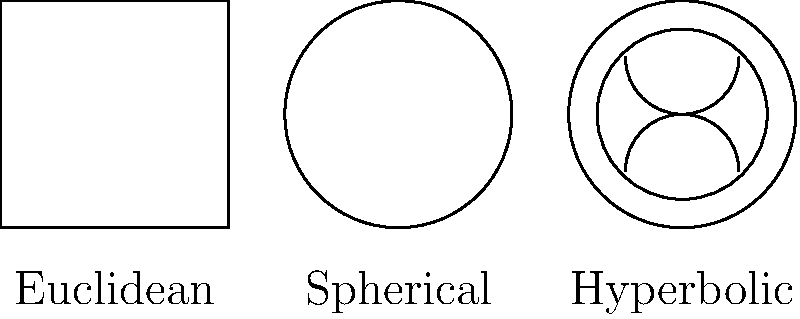In the context of implementing SharePoint solutions, understanding different geometric models can be useful for designing user interfaces and data visualizations. Consider the diagram showing Euclidean, spherical, and hyperbolic geometries. Which of these geometries allows for the existence of parallel lines, and how does this property differ in the other geometries? To answer this question, let's analyze each geometry:

1. Euclidean Geometry:
   - Parallel lines exist and never intersect.
   - The sum of angles in a triangle is always 180°.

2. Spherical Geometry:
   - No parallel lines exist; all great circles (the equivalent of straight lines on a sphere) eventually intersect.
   - The sum of angles in a triangle is always greater than 180°.

3. Hyperbolic Geometry:
   - Multiple parallel lines can exist through a point not on a given line.
   - The sum of angles in a triangle is always less than 180°.

In the context of SharePoint:
- Euclidean geometry is most commonly used in traditional 2D interfaces.
- Spherical geometry could be useful for global data visualization or 360° content presentation.
- Hyperbolic geometry can be applied to visualize hierarchical structures or complex networks, allowing for more efficient use of space in large datasets.

The key difference is that only Euclidean geometry allows for the existence of parallel lines in the traditional sense. In spherical geometry, all lines (great circles) intersect, while in hyperbolic geometry, multiple parallels can exist through a point not on a given line.
Answer: Euclidean geometry allows parallel lines; spherical has no parallels; hyperbolic has multiple parallels. 